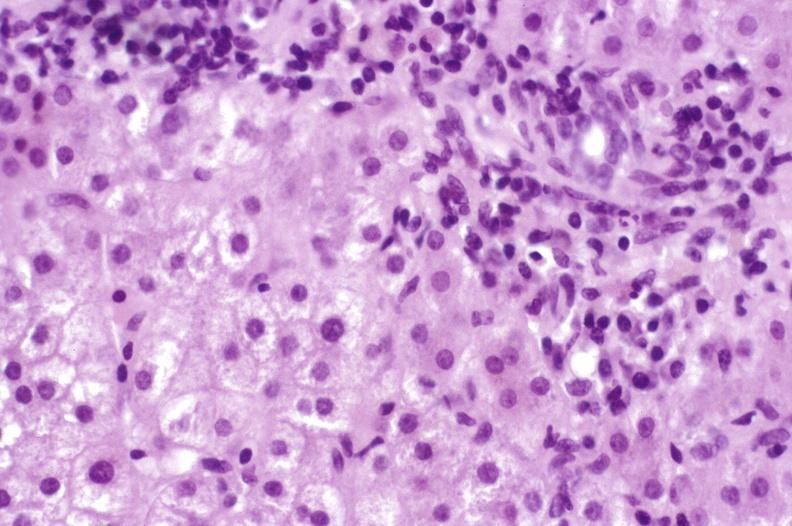does this image show primary biliary cirrhosis?
Answer the question using a single word or phrase. Yes 